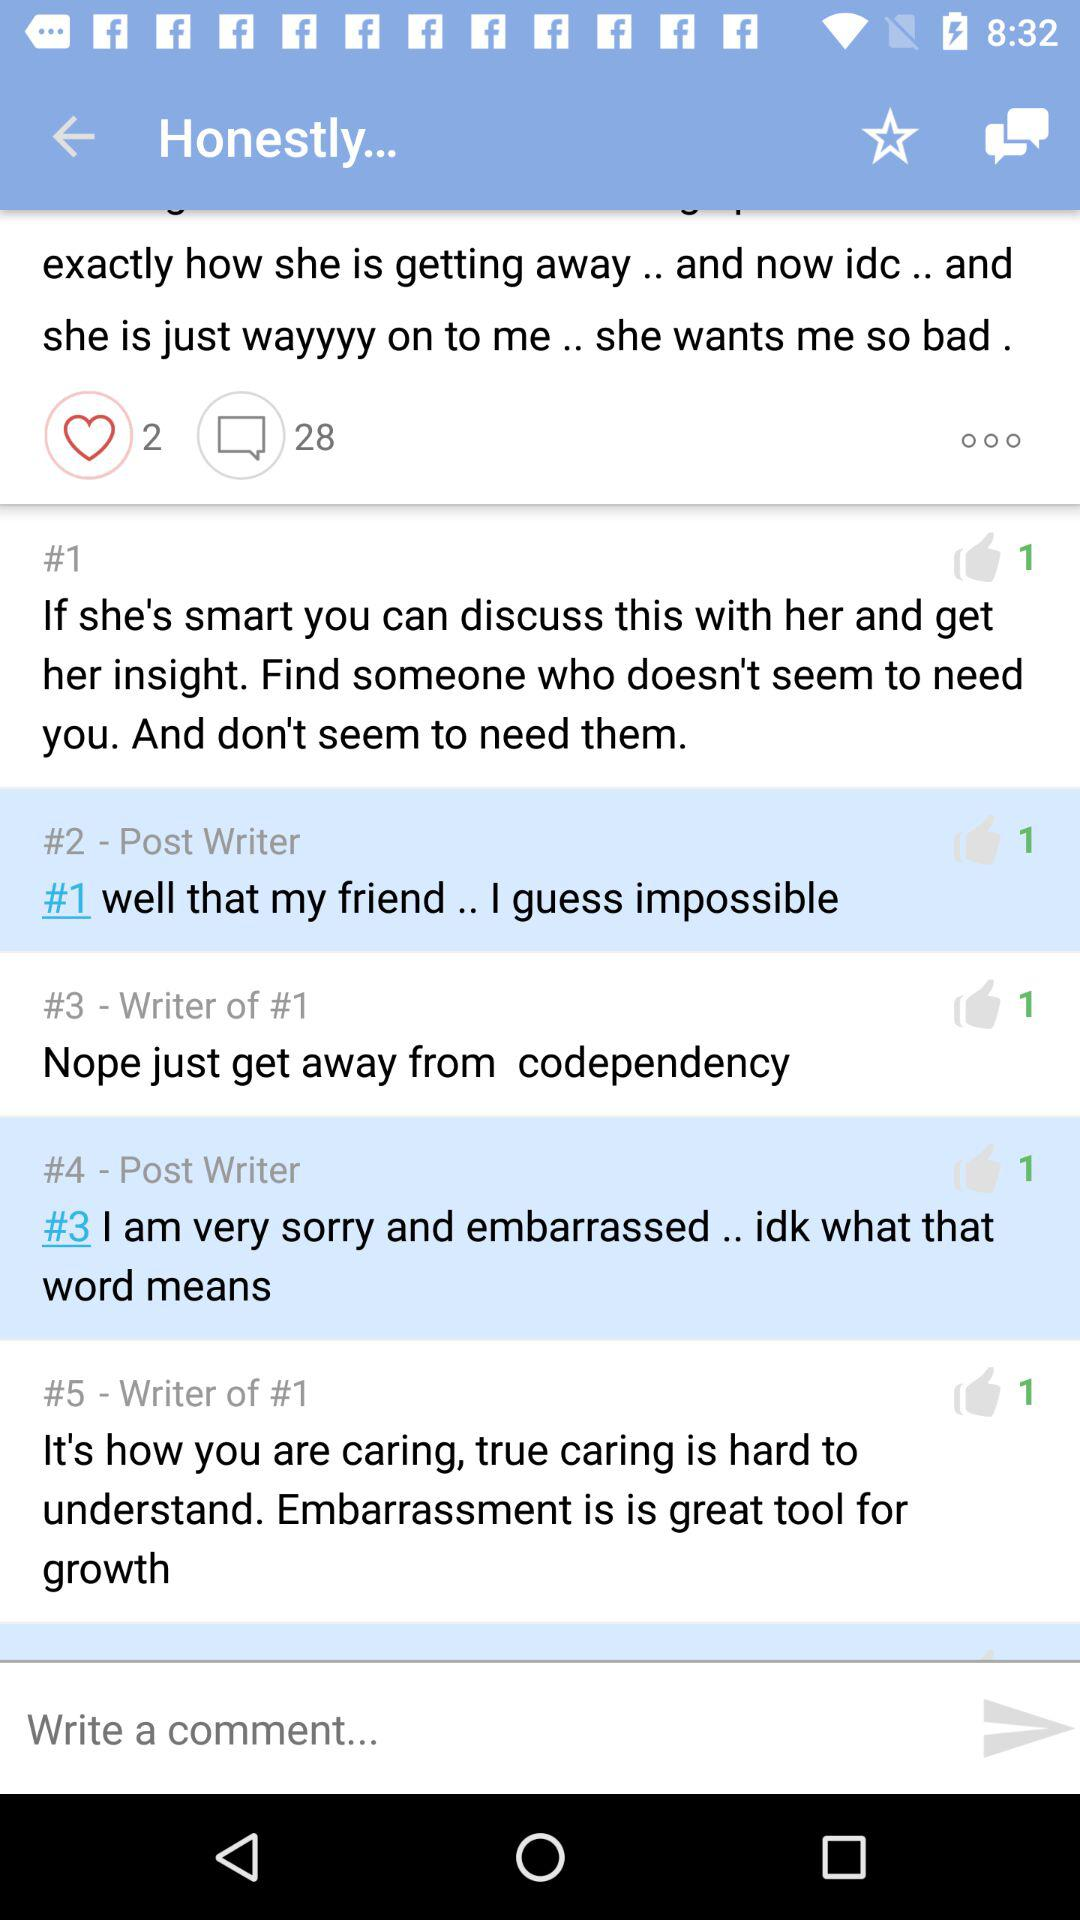How many likes are there of #1? There is 1 like of #1. 